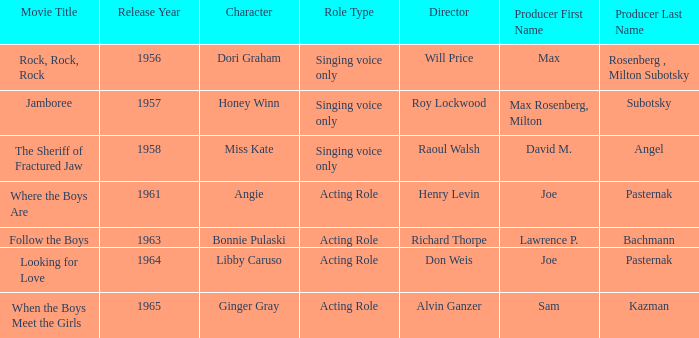What motion picture was created in 1957? Jamboree. 